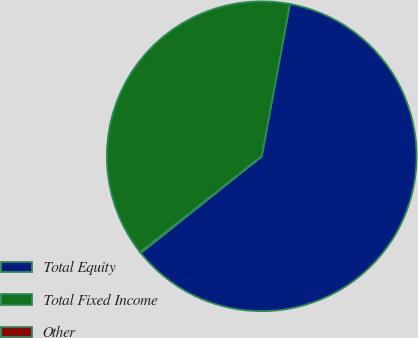<chart> <loc_0><loc_0><loc_500><loc_500><pie_chart><fcel>Total Equity<fcel>Total Fixed Income<fcel>Other<nl><fcel>61.35%<fcel>38.54%<fcel>0.12%<nl></chart> 